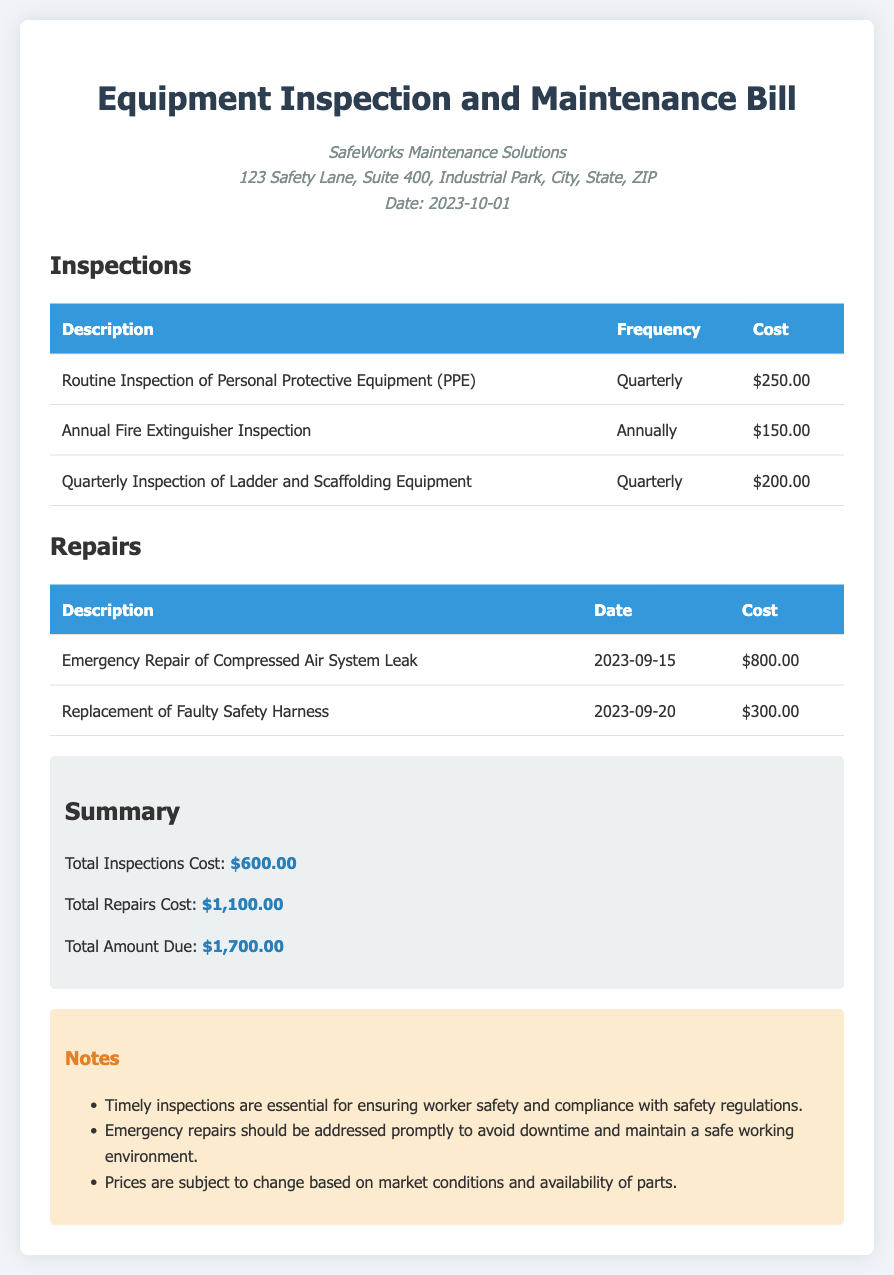what is the total inspections cost? The total inspections cost is stated in the summary section of the document, which is $600.00.
Answer: $600.00 what is the cost of the annual fire extinguisher inspection? The cost of the annual fire extinguisher inspection is listed in the inspections table, which is $150.00.
Answer: $150.00 how many emergency repairs are listed in the document? There are two emergency repairs listed in the repairs section, as shown in the table.
Answer: 2 when was the emergency repair of the compressed air system leak conducted? The date of the emergency repair is included in the repairs table, which shows it was conducted on 2023-09-15.
Answer: 2023-09-15 what is the total amount due? The total amount due is summarized at the end of the document as $1,700.00.
Answer: $1,700.00 how often is the routine inspection of personal protective equipment (PPE) conducted? The frequency of the routine inspection of PPE is mentioned in the inspections table, which indicates it is conducted quarterly.
Answer: Quarterly what is the date of the replacement of the faulty safety harness? The date is specified in the repairs table for the replacement, which is 2023-09-20.
Answer: 2023-09-20 what note is emphasized regarding timely inspections? One note emphasizes that timely inspections are essential for ensuring worker safety and compliance with safety regulations.
Answer: Worker safety what is the cost of the quarterly inspection of ladder and scaffolding equipment? The cost is mentioned in the inspections table as $200.00 for the quarterly inspection of ladder and scaffolding equipment.
Answer: $200.00 